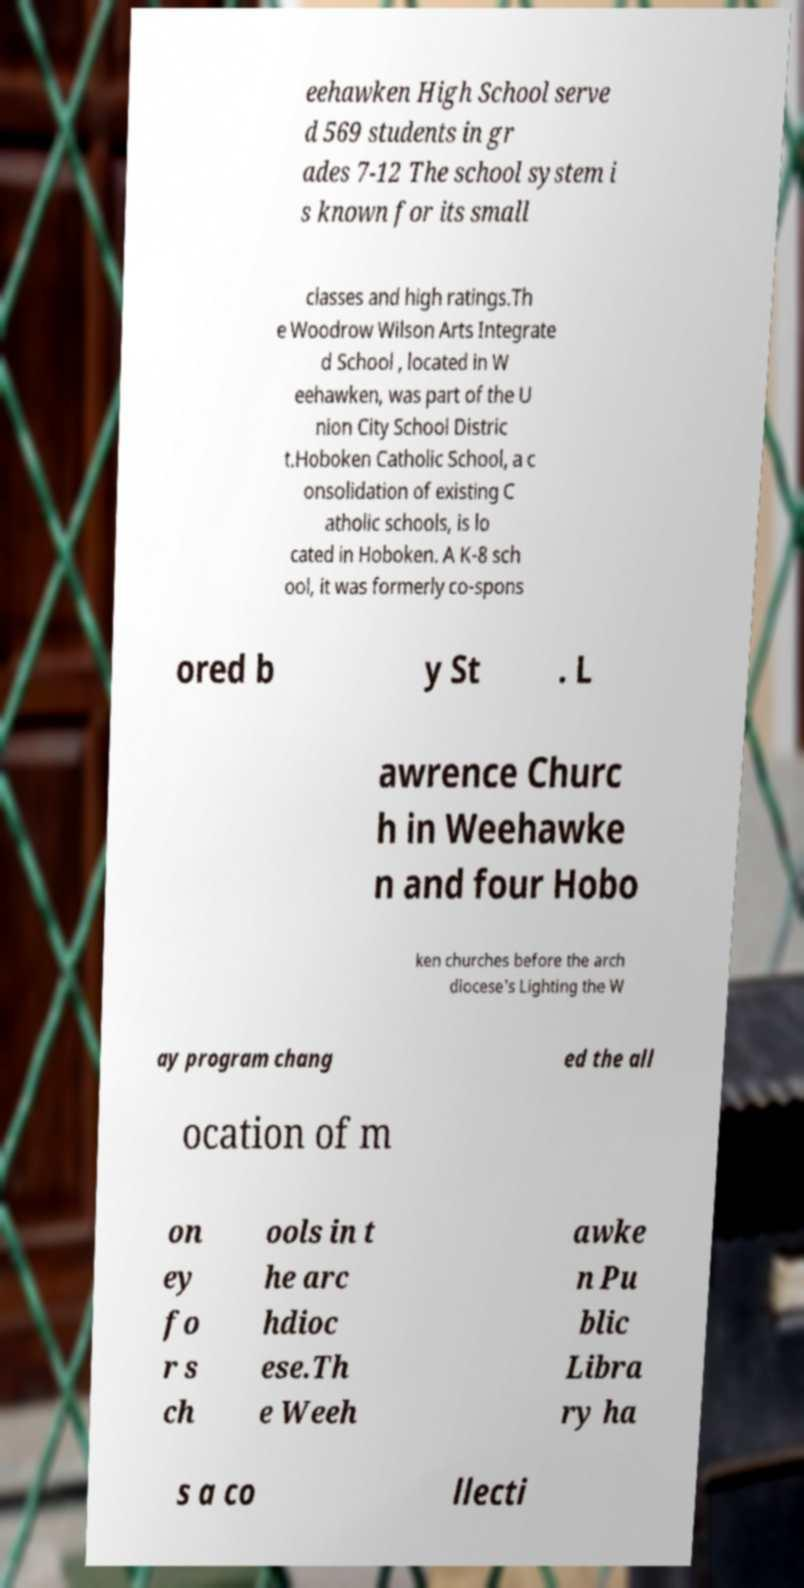Can you read and provide the text displayed in the image?This photo seems to have some interesting text. Can you extract and type it out for me? eehawken High School serve d 569 students in gr ades 7-12 The school system i s known for its small classes and high ratings.Th e Woodrow Wilson Arts Integrate d School , located in W eehawken, was part of the U nion City School Distric t.Hoboken Catholic School, a c onsolidation of existing C atholic schools, is lo cated in Hoboken. A K-8 sch ool, it was formerly co-spons ored b y St . L awrence Churc h in Weehawke n and four Hobo ken churches before the arch diocese's Lighting the W ay program chang ed the all ocation of m on ey fo r s ch ools in t he arc hdioc ese.Th e Weeh awke n Pu blic Libra ry ha s a co llecti 